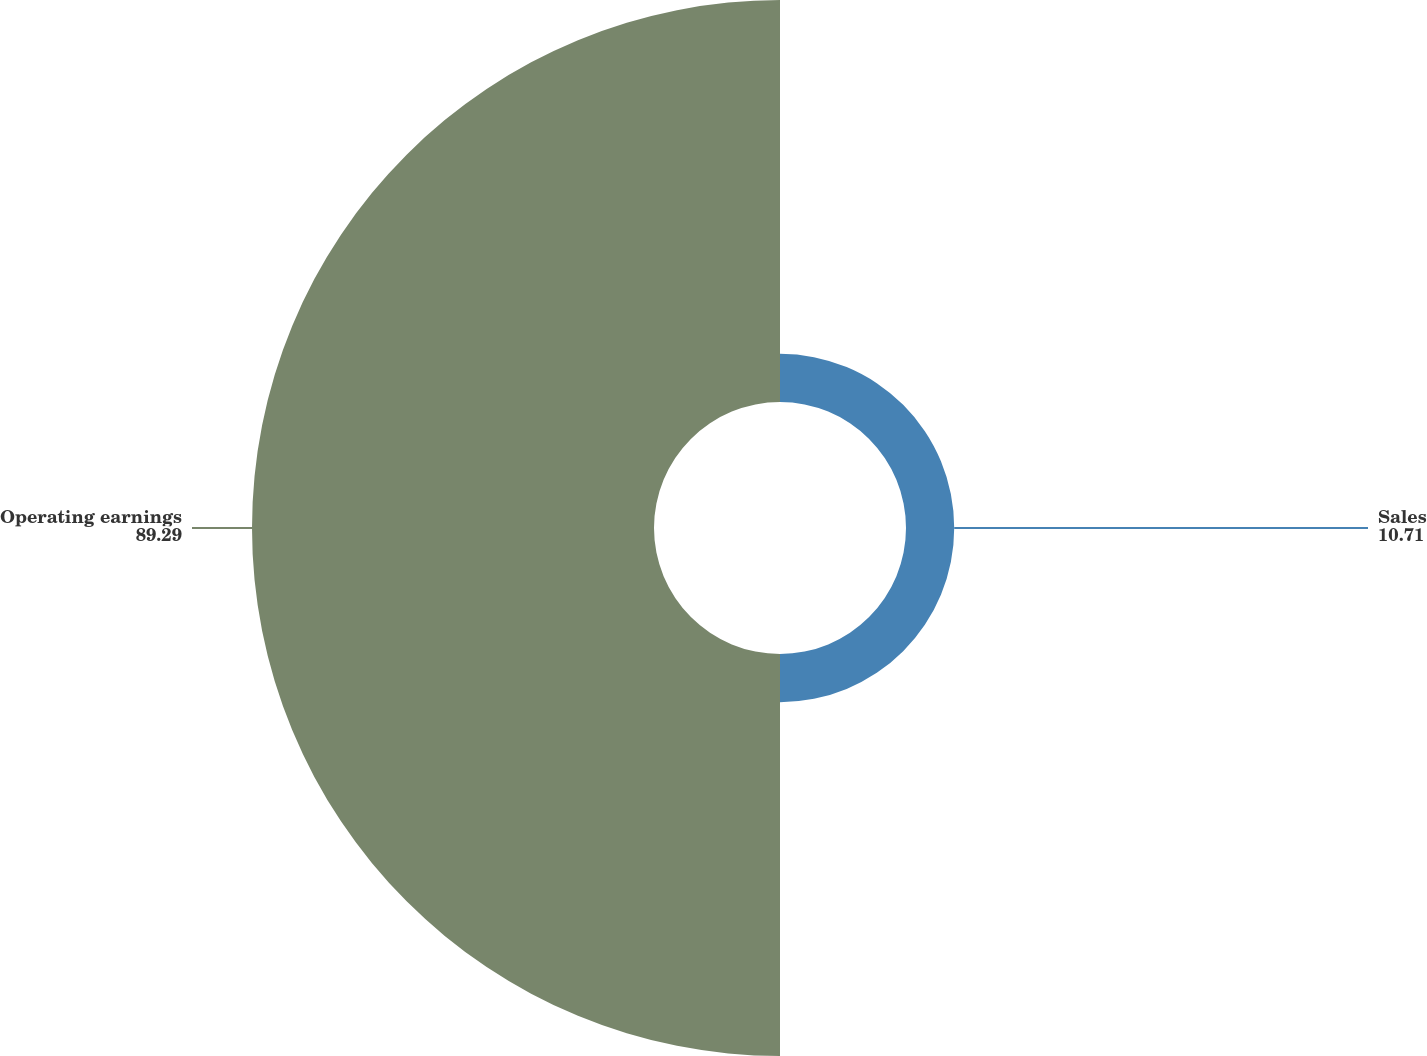Convert chart to OTSL. <chart><loc_0><loc_0><loc_500><loc_500><pie_chart><fcel>Sales<fcel>Operating earnings<nl><fcel>10.71%<fcel>89.29%<nl></chart> 